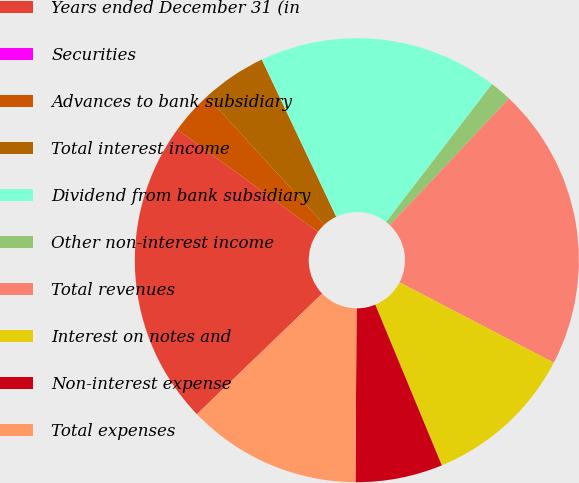Convert chart. <chart><loc_0><loc_0><loc_500><loc_500><pie_chart><fcel>Years ended December 31 (in<fcel>Securities<fcel>Advances to bank subsidiary<fcel>Total interest income<fcel>Dividend from bank subsidiary<fcel>Other non-interest income<fcel>Total revenues<fcel>Interest on notes and<fcel>Non-interest expense<fcel>Total expenses<nl><fcel>22.22%<fcel>0.0%<fcel>3.18%<fcel>4.76%<fcel>17.46%<fcel>1.59%<fcel>20.63%<fcel>11.11%<fcel>6.35%<fcel>12.7%<nl></chart> 